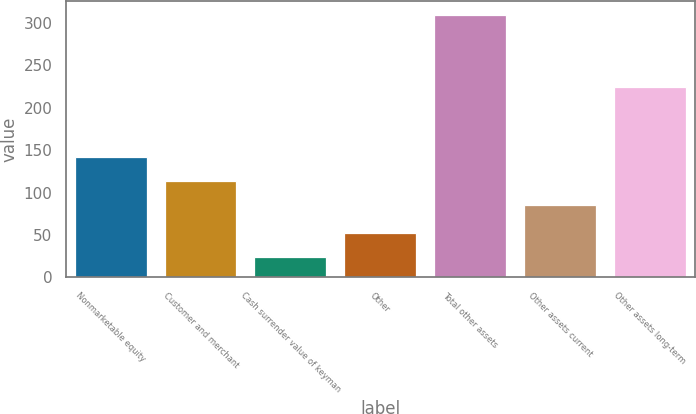Convert chart to OTSL. <chart><loc_0><loc_0><loc_500><loc_500><bar_chart><fcel>Nonmarketable equity<fcel>Customer and merchant<fcel>Cash surrender value of keyman<fcel>Other<fcel>Total other assets<fcel>Other assets current<fcel>Other assets long-term<nl><fcel>142.2<fcel>113.6<fcel>24<fcel>52.6<fcel>310<fcel>85<fcel>225<nl></chart> 